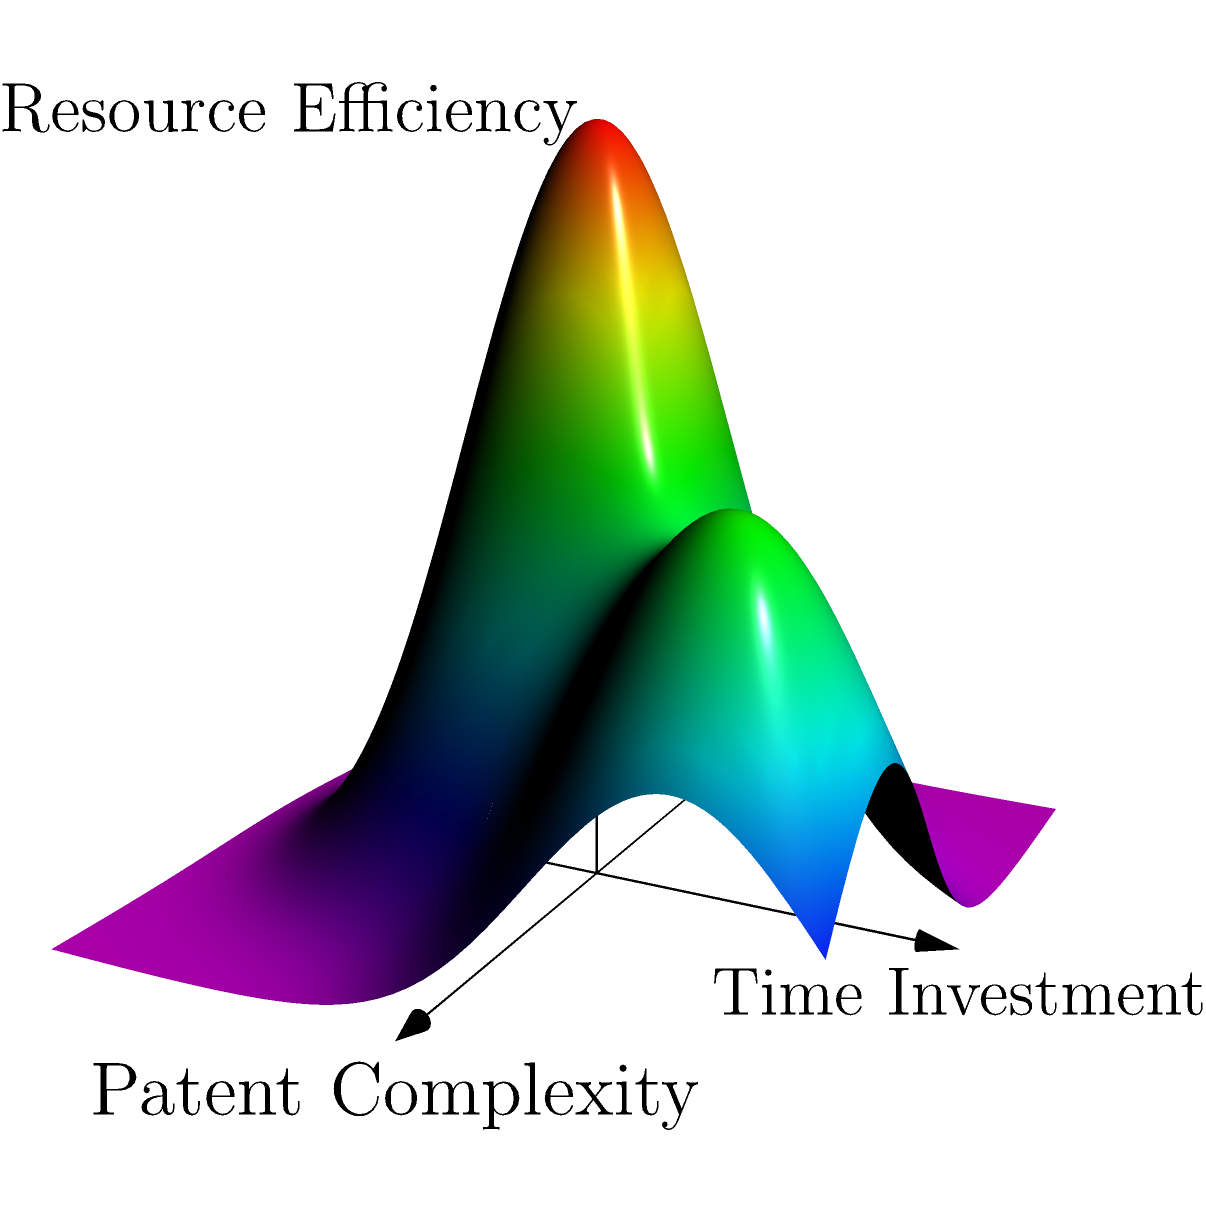As a competitor's attorney challenging patent validity, you're analyzing the efficiency of resource allocation across multiple patent disputes. The surface plot represents the resource efficiency (z-axis) as a function of patent complexity (x-axis) and time investment (y-axis). Find the critical points of this function and determine the optimal resource allocation strategy to maximize efficiency. To solve this problem, we need to follow these steps:

1) The surface plot represents a function $f(x,y)$ where:
   $x$ is the patent complexity
   $y$ is the time investment
   $z = f(x,y)$ is the resource efficiency

2) From the plot, we can see that the function appears to have two local maxima. To find these critical points, we would need to:
   a) Find the partial derivatives $\frac{\partial f}{\partial x}$ and $\frac{\partial f}{\partial y}$
   b) Set both partial derivatives to zero and solve the resulting system of equations

3) However, without the exact function, we can estimate the critical points visually:
   - One peak appears to be at approximately $(x,y) = (0,0)$
   - Another peak appears to be at approximately $(x,y) = (2,2)$

4) Interpreting these results:
   - The peak at $(0,0)$ suggests that for simpler patents (low complexity), a minimal time investment can yield high efficiency.
   - The peak at $(2,2)$ suggests that for more complex patents, a higher time investment is needed to achieve high efficiency.

5) Optimal strategy:
   - For simpler patent disputes, allocate minimal resources and time.
   - For more complex patent disputes, allocate more resources and time.
   - Avoid the "valley" between these peaks, as it represents inefficient resource allocation.

6) The overall strategy should be to classify patent disputes based on their complexity and allocate resources accordingly, rather than applying a one-size-fits-all approach.
Answer: Allocate minimal resources for simple patents; invest more time and resources for complex patents. 